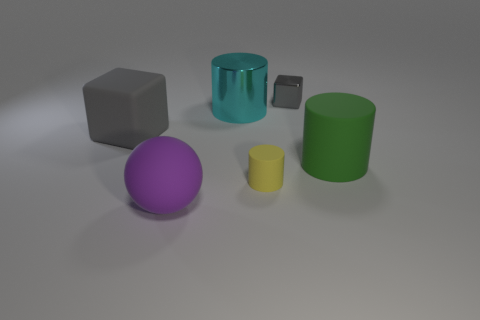Add 2 tiny blocks. How many objects exist? 8 Subtract all spheres. How many objects are left? 5 Subtract all large purple things. Subtract all green objects. How many objects are left? 4 Add 2 gray cubes. How many gray cubes are left? 4 Add 4 balls. How many balls exist? 5 Subtract 0 green cubes. How many objects are left? 6 